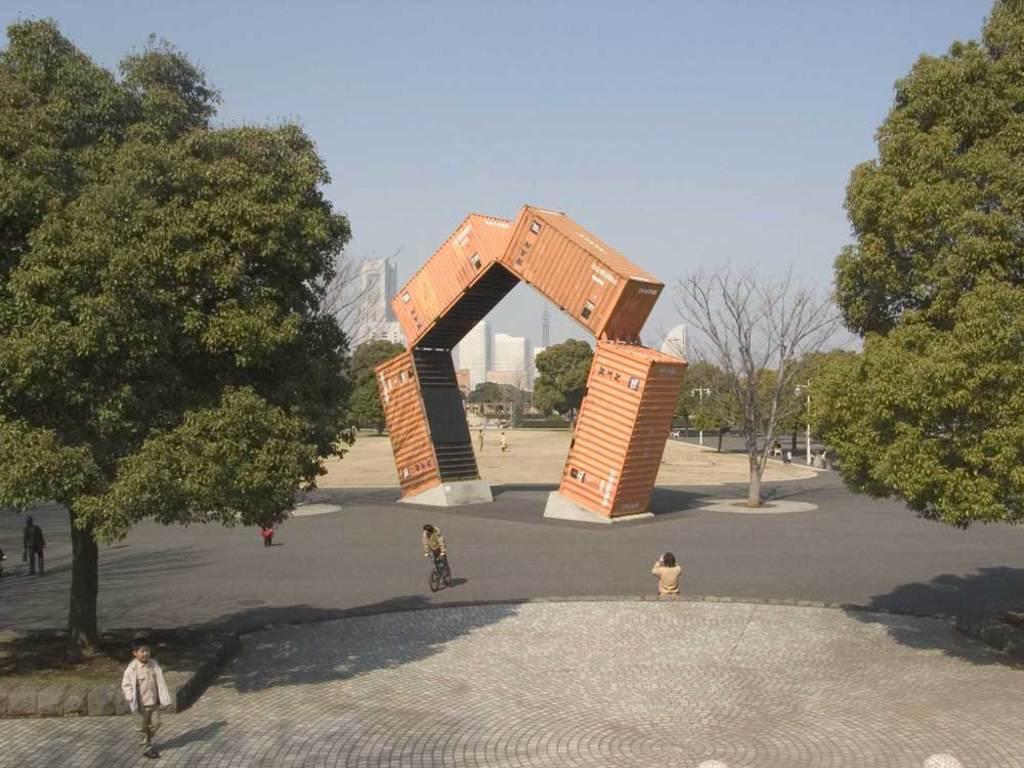How would you summarize this image in a sentence or two? In this image on both sides there are trees. Here there is a arch. There are few people over here on the road. In the background there are trees and buildings. The sky is clear. 